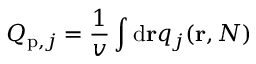Convert formula to latex. <formula><loc_0><loc_0><loc_500><loc_500>Q _ { p , j } = \frac { 1 } { v } \int d r q _ { j } ( r , N )</formula> 